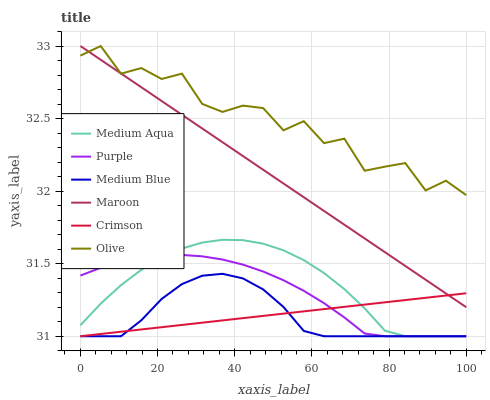Does Medium Blue have the minimum area under the curve?
Answer yes or no. Yes. Does Olive have the maximum area under the curve?
Answer yes or no. Yes. Does Maroon have the minimum area under the curve?
Answer yes or no. No. Does Maroon have the maximum area under the curve?
Answer yes or no. No. Is Crimson the smoothest?
Answer yes or no. Yes. Is Olive the roughest?
Answer yes or no. Yes. Is Medium Blue the smoothest?
Answer yes or no. No. Is Medium Blue the roughest?
Answer yes or no. No. Does Purple have the lowest value?
Answer yes or no. Yes. Does Maroon have the lowest value?
Answer yes or no. No. Does Olive have the highest value?
Answer yes or no. Yes. Does Medium Blue have the highest value?
Answer yes or no. No. Is Medium Aqua less than Maroon?
Answer yes or no. Yes. Is Maroon greater than Medium Blue?
Answer yes or no. Yes. Does Crimson intersect Medium Blue?
Answer yes or no. Yes. Is Crimson less than Medium Blue?
Answer yes or no. No. Is Crimson greater than Medium Blue?
Answer yes or no. No. Does Medium Aqua intersect Maroon?
Answer yes or no. No. 